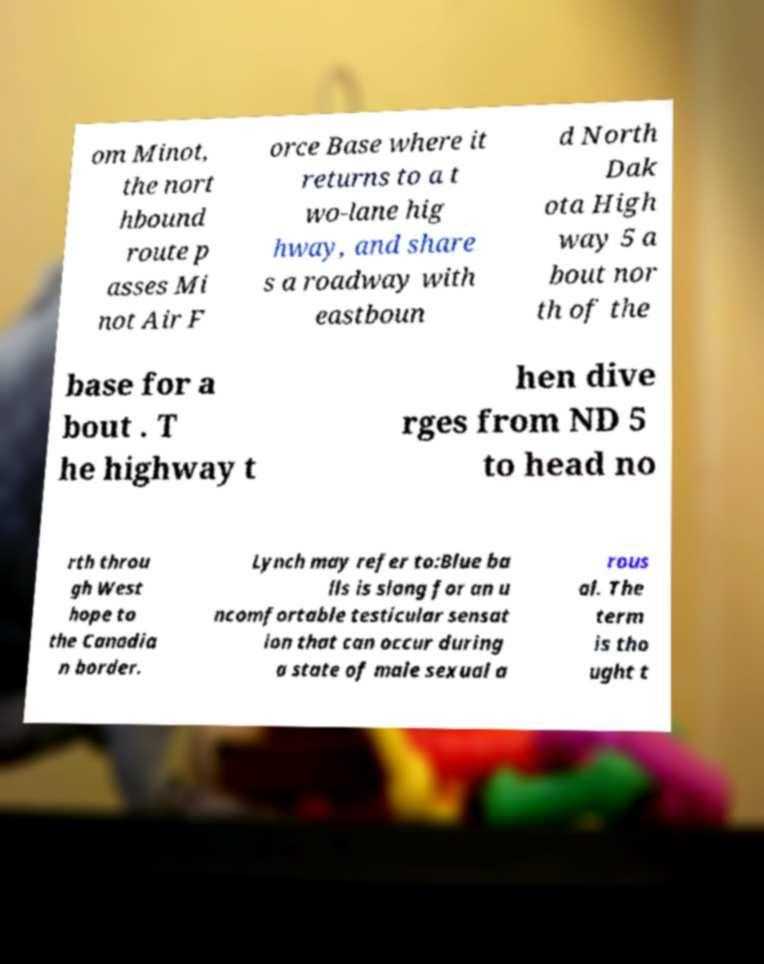What messages or text are displayed in this image? I need them in a readable, typed format. om Minot, the nort hbound route p asses Mi not Air F orce Base where it returns to a t wo-lane hig hway, and share s a roadway with eastboun d North Dak ota High way 5 a bout nor th of the base for a bout . T he highway t hen dive rges from ND 5 to head no rth throu gh West hope to the Canadia n border. Lynch may refer to:Blue ba lls is slang for an u ncomfortable testicular sensat ion that can occur during a state of male sexual a rous al. The term is tho ught t 